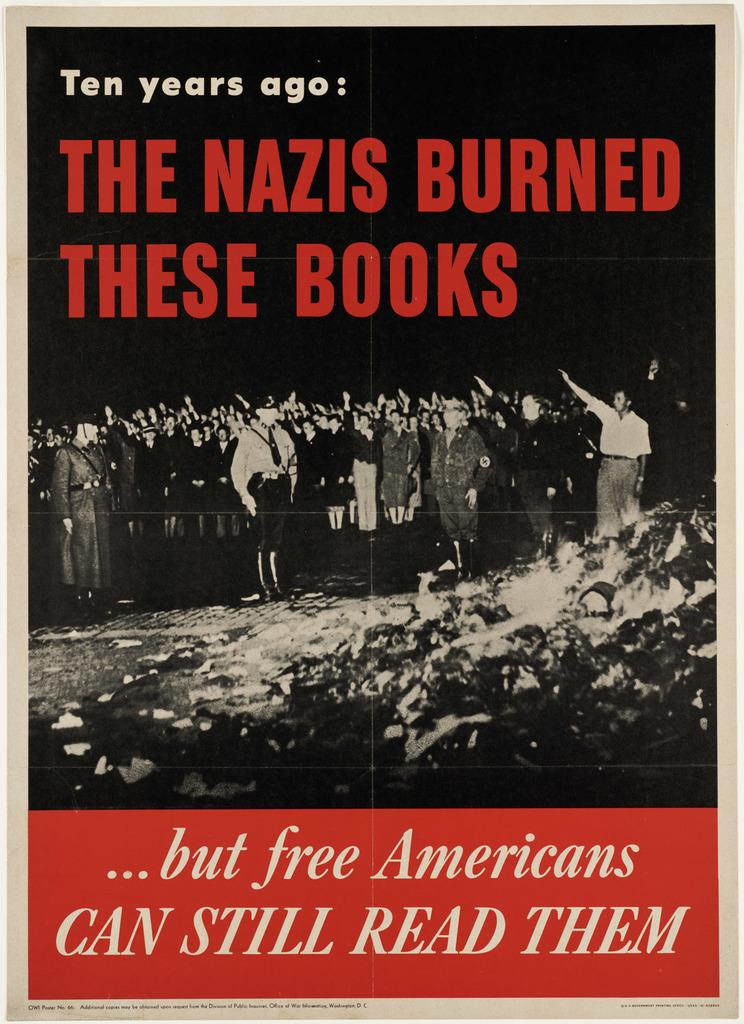<image>
Create a compact narrative representing the image presented. A poster of people hailing nazis and discussing the nazis burning books. 